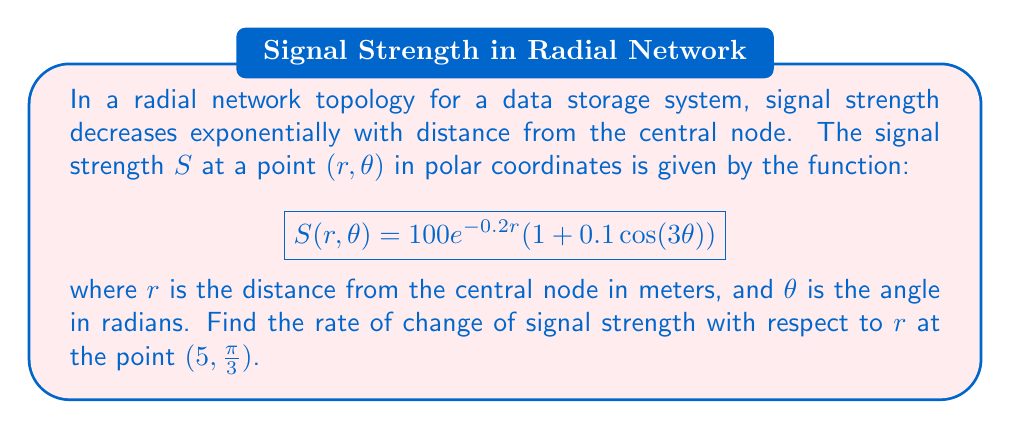Solve this math problem. To find the rate of change of signal strength with respect to $r$, we need to calculate the partial derivative of $S$ with respect to $r$ at the given point.

1. First, let's calculate $\frac{\partial S}{\partial r}$:

   $$\frac{\partial S}{\partial r} = -0.2 \cdot 100e^{-0.2r}(1 + 0.1\cos(3\theta))$$
   $$\frac{\partial S}{\partial r} = -20e^{-0.2r}(1 + 0.1\cos(3\theta))$$

2. Now, we need to evaluate this at the point $(5, \frac{\pi}{3})$:

   $$\left.\frac{\partial S}{\partial r}\right|_{(5,\frac{\pi}{3})} = -20e^{-0.2(5)}(1 + 0.1\cos(3\cdot\frac{\pi}{3}))$$

3. Let's calculate the parts:
   
   $e^{-0.2(5)} = e^{-1} \approx 0.3679$
   
   $\cos(3\cdot\frac{\pi}{3}) = \cos(\pi) = -1$

4. Substituting these values:

   $$\left.\frac{\partial S}{\partial r}\right|_{(5,\frac{\pi}{3})} = -20 \cdot 0.3679 \cdot (1 + 0.1(-1))$$
   $$= -20 \cdot 0.3679 \cdot 0.9$$
   $$\approx -6.6222$$

The negative value indicates that the signal strength is decreasing as $r$ increases, which is expected given the exponential decay in the model.
Answer: $-6.6222$ units per meter (approximately) 